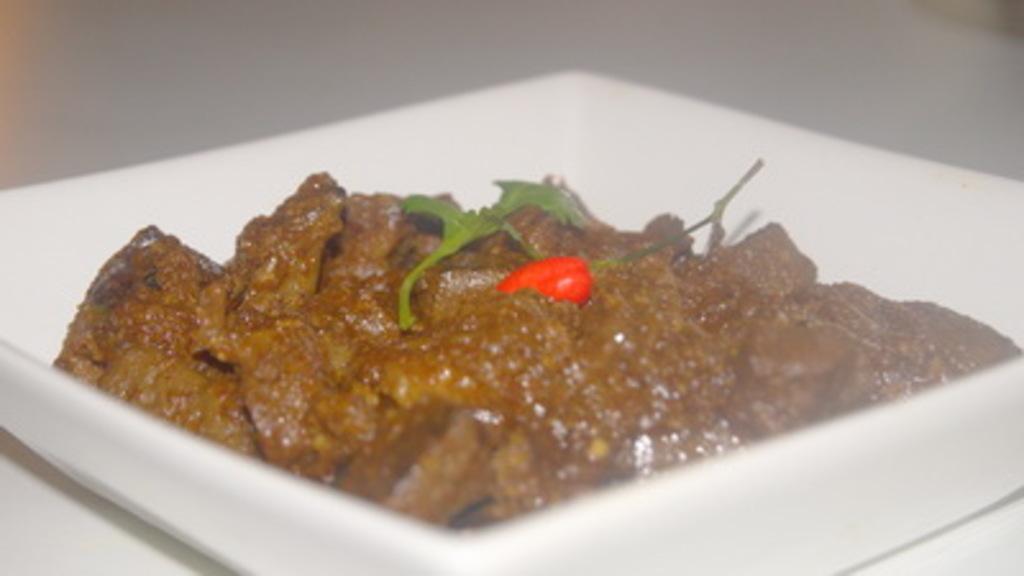How would you summarize this image in a sentence or two? This image is taken indoors. At the bottom of the image there is a table with a plate on it and on the plate there is a food item. 